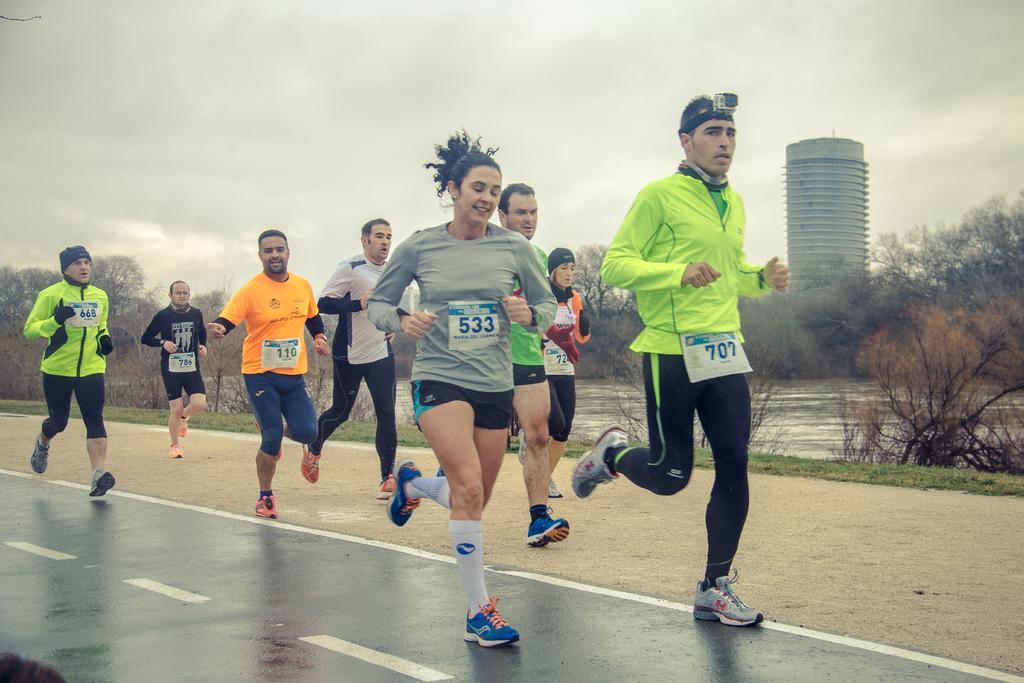In one or two sentences, can you explain what this image depicts? In this image, I can see a group of people running on the road. In the background, there are trees, water, grass, a building and the sky. 